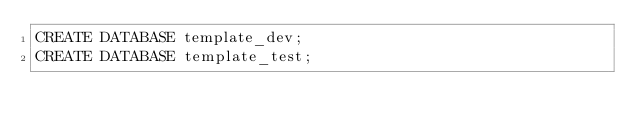Convert code to text. <code><loc_0><loc_0><loc_500><loc_500><_SQL_>CREATE DATABASE template_dev;
CREATE DATABASE template_test;
</code> 